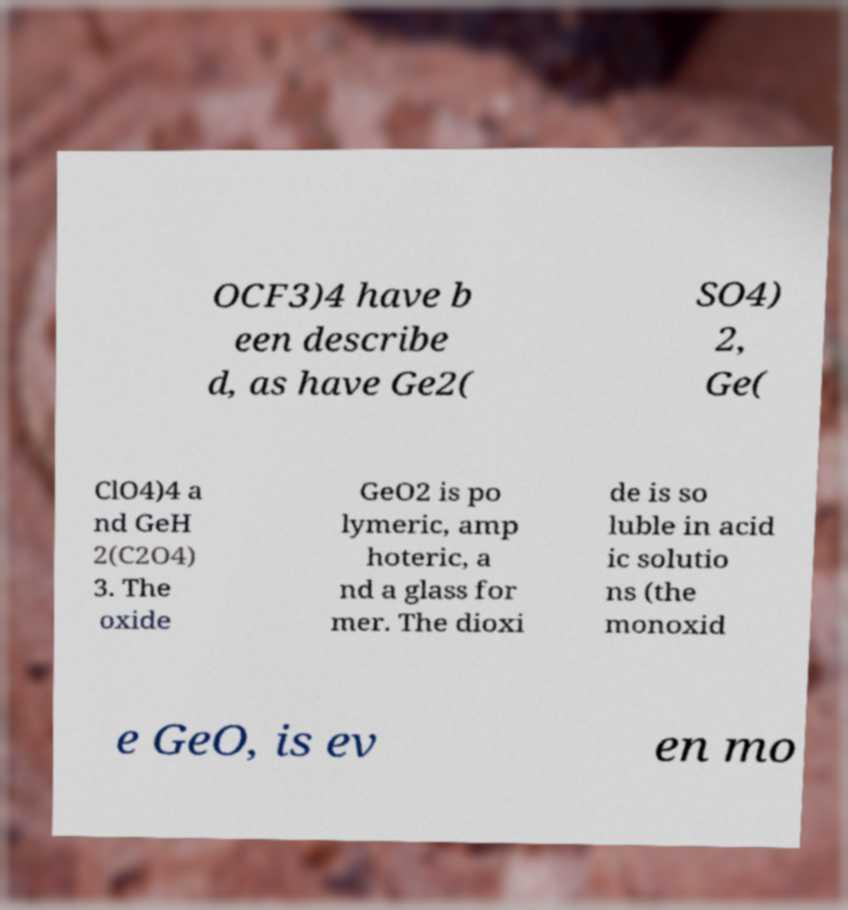Can you accurately transcribe the text from the provided image for me? OCF3)4 have b een describe d, as have Ge2( SO4) 2, Ge( ClO4)4 a nd GeH 2(C2O4) 3. The oxide GeO2 is po lymeric, amp hoteric, a nd a glass for mer. The dioxi de is so luble in acid ic solutio ns (the monoxid e GeO, is ev en mo 